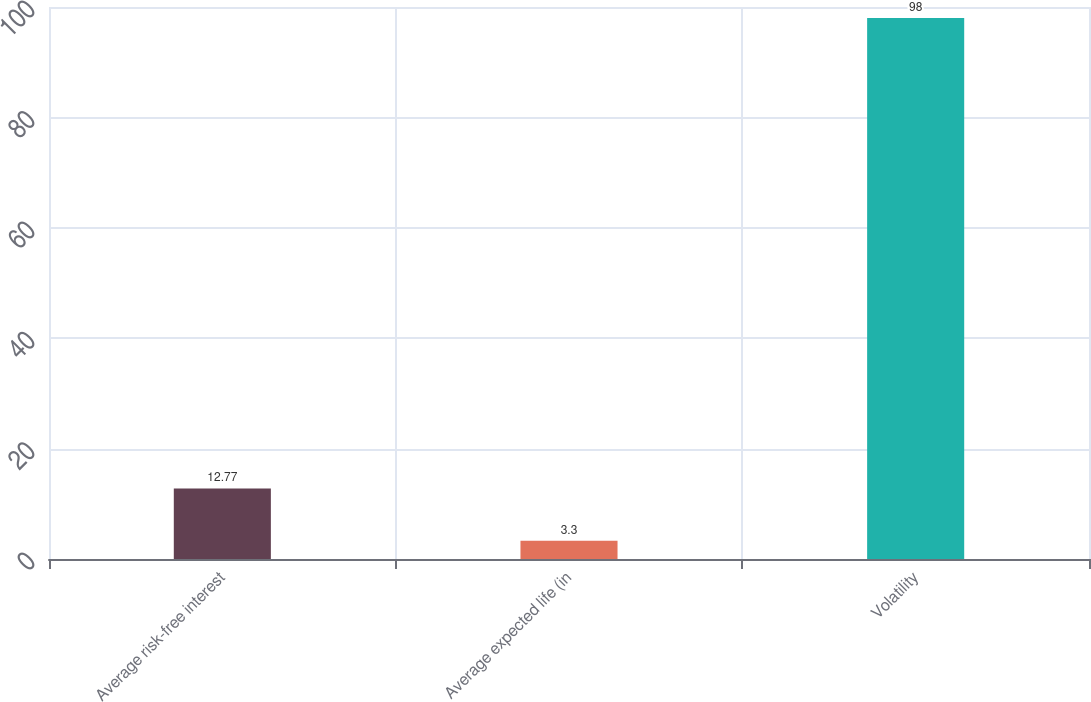<chart> <loc_0><loc_0><loc_500><loc_500><bar_chart><fcel>Average risk-free interest<fcel>Average expected life (in<fcel>Volatility<nl><fcel>12.77<fcel>3.3<fcel>98<nl></chart> 